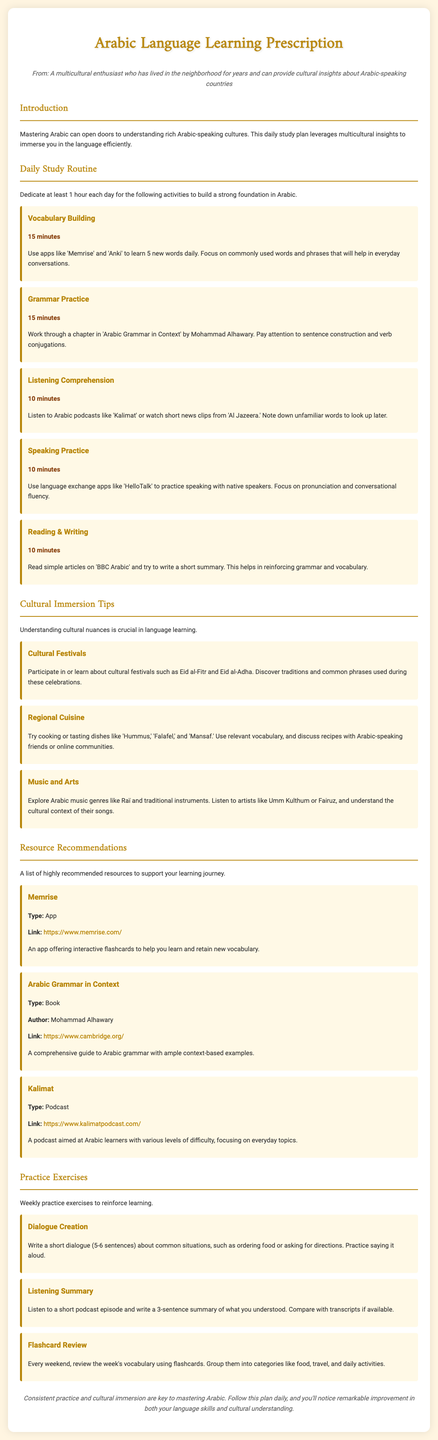What is the title of the document? The title is clearly stated in the document header section and reads "Arabic Language Learning Prescription."
Answer: Arabic Language Learning Prescription How many minutes are dedicated to Vocabulary Building each day? The specific time for Vocabulary Building is mentioned in the daily study routine section, which is 15 minutes.
Answer: 15 minutes Which app is recommended for Vocabulary Building? The document explicitly mentions the app 'Memrise' for building vocabulary.
Answer: Memrise What is the name of the book for Grammar Practice? The document lists "Arabic Grammar in Context" as the book for Grammar Practice.
Answer: Arabic Grammar in Context How long should the total daily study time be? The document specifies at least 1 hour should be dedicated to the daily study plan.
Answer: 1 hour What are the two cultural festivals mentioned? The document highlights "Eid al-Fitr" and "Eid al-Adha" as significant cultural festivals.
Answer: Eid al-Fitr and Eid al-Adha Who is the author of the recommended grammar book? The document provides the author's name, which is Mohammad Alhawary.
Answer: Mohammad Alhawary How many sentences should the dialogue creation exercise contain? The exercise indicates that the dialogue should be 5-6 sentences long.
Answer: 5-6 sentences What is the listening exercise focused on? The listening exercise requires you to write a summary after listening, focusing on what you understood.
Answer: Listening summary 